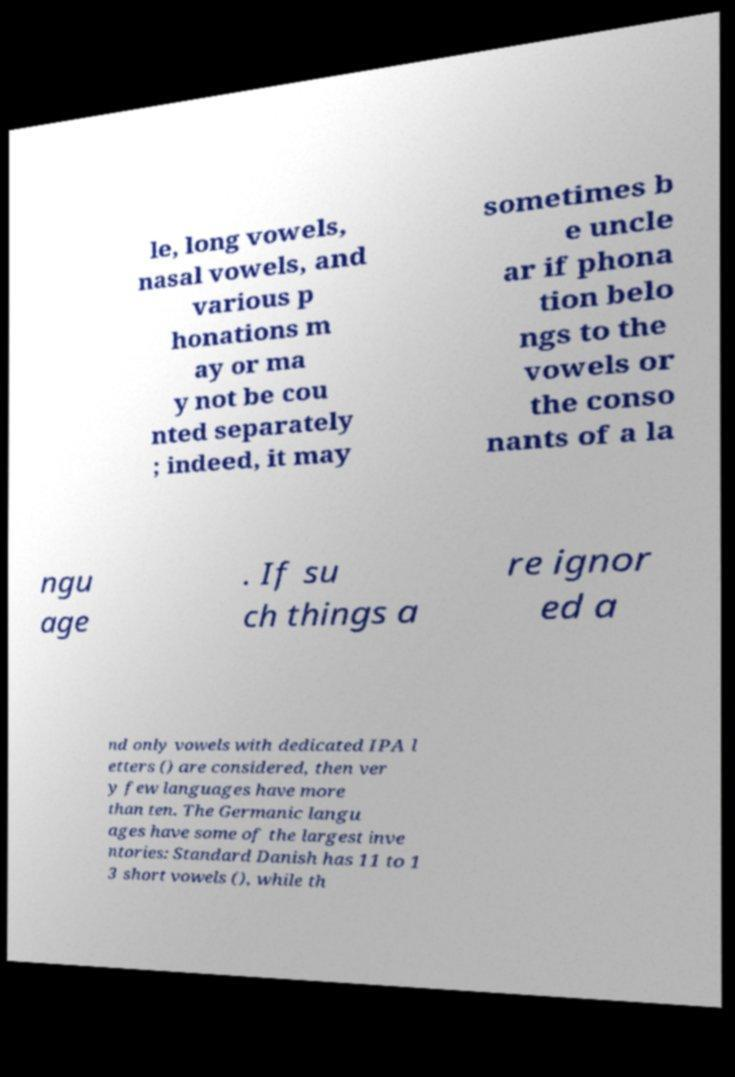Can you read and provide the text displayed in the image?This photo seems to have some interesting text. Can you extract and type it out for me? le, long vowels, nasal vowels, and various p honations m ay or ma y not be cou nted separately ; indeed, it may sometimes b e uncle ar if phona tion belo ngs to the vowels or the conso nants of a la ngu age . If su ch things a re ignor ed a nd only vowels with dedicated IPA l etters () are considered, then ver y few languages have more than ten. The Germanic langu ages have some of the largest inve ntories: Standard Danish has 11 to 1 3 short vowels (), while th 